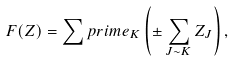Convert formula to latex. <formula><loc_0><loc_0><loc_500><loc_500>F ( Z ) = \sum p r i m e _ { K } \left ( \pm \sum _ { J \sim K } Z _ { J } \right ) ,</formula> 